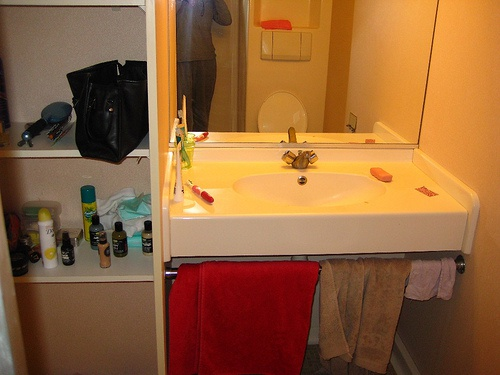Describe the objects in this image and their specific colors. I can see sink in gray, orange, and tan tones, handbag in gray and black tones, people in gray, black, and maroon tones, toilet in gray and orange tones, and bottle in gray, darkgray, and olive tones in this image. 